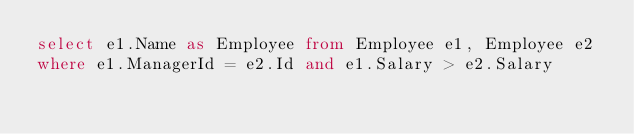Convert code to text. <code><loc_0><loc_0><loc_500><loc_500><_SQL_>select e1.Name as Employee from Employee e1, Employee e2
where e1.ManagerId = e2.Id and e1.Salary > e2.Salary</code> 